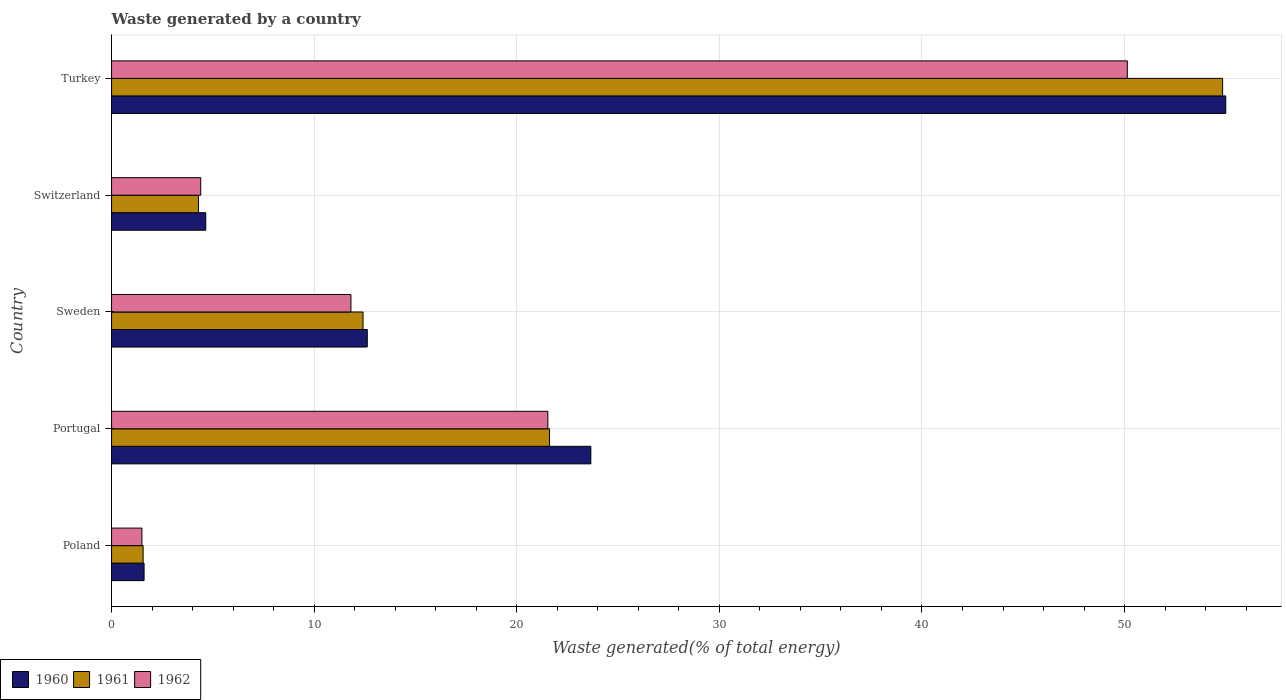How many different coloured bars are there?
Offer a very short reply. 3. Are the number of bars per tick equal to the number of legend labels?
Keep it short and to the point. Yes. Are the number of bars on each tick of the Y-axis equal?
Your answer should be compact. Yes. How many bars are there on the 1st tick from the bottom?
Provide a short and direct response. 3. What is the label of the 3rd group of bars from the top?
Provide a short and direct response. Sweden. What is the total waste generated in 1961 in Portugal?
Provide a succinct answer. 21.62. Across all countries, what is the maximum total waste generated in 1961?
Offer a very short reply. 54.84. Across all countries, what is the minimum total waste generated in 1961?
Provide a short and direct response. 1.56. In which country was the total waste generated in 1961 minimum?
Offer a terse response. Poland. What is the total total waste generated in 1962 in the graph?
Give a very brief answer. 89.39. What is the difference between the total waste generated in 1961 in Poland and that in Sweden?
Your answer should be very brief. -10.85. What is the difference between the total waste generated in 1961 in Switzerland and the total waste generated in 1960 in Portugal?
Give a very brief answer. -19.36. What is the average total waste generated in 1960 per country?
Provide a short and direct response. 19.51. What is the difference between the total waste generated in 1960 and total waste generated in 1961 in Poland?
Offer a very short reply. 0.05. What is the ratio of the total waste generated in 1961 in Poland to that in Sweden?
Provide a succinct answer. 0.13. Is the total waste generated in 1962 in Portugal less than that in Sweden?
Provide a succinct answer. No. Is the difference between the total waste generated in 1960 in Portugal and Turkey greater than the difference between the total waste generated in 1961 in Portugal and Turkey?
Provide a succinct answer. Yes. What is the difference between the highest and the second highest total waste generated in 1961?
Your answer should be compact. 33.22. What is the difference between the highest and the lowest total waste generated in 1960?
Ensure brevity in your answer.  53.39. In how many countries, is the total waste generated in 1960 greater than the average total waste generated in 1960 taken over all countries?
Provide a succinct answer. 2. Is the sum of the total waste generated in 1962 in Portugal and Sweden greater than the maximum total waste generated in 1960 across all countries?
Your answer should be very brief. No. Is it the case that in every country, the sum of the total waste generated in 1961 and total waste generated in 1960 is greater than the total waste generated in 1962?
Provide a succinct answer. Yes. Are all the bars in the graph horizontal?
Your answer should be very brief. Yes. How many countries are there in the graph?
Your answer should be very brief. 5. Does the graph contain any zero values?
Give a very brief answer. No. Does the graph contain grids?
Provide a succinct answer. Yes. What is the title of the graph?
Ensure brevity in your answer.  Waste generated by a country. What is the label or title of the X-axis?
Ensure brevity in your answer.  Waste generated(% of total energy). What is the label or title of the Y-axis?
Your answer should be compact. Country. What is the Waste generated(% of total energy) of 1960 in Poland?
Offer a terse response. 1.6. What is the Waste generated(% of total energy) of 1961 in Poland?
Your response must be concise. 1.56. What is the Waste generated(% of total energy) of 1962 in Poland?
Provide a short and direct response. 1.5. What is the Waste generated(% of total energy) of 1960 in Portugal?
Make the answer very short. 23.66. What is the Waste generated(% of total energy) in 1961 in Portugal?
Provide a short and direct response. 21.62. What is the Waste generated(% of total energy) in 1962 in Portugal?
Ensure brevity in your answer.  21.53. What is the Waste generated(% of total energy) in 1960 in Sweden?
Make the answer very short. 12.62. What is the Waste generated(% of total energy) of 1961 in Sweden?
Ensure brevity in your answer.  12.41. What is the Waste generated(% of total energy) of 1962 in Sweden?
Provide a succinct answer. 11.82. What is the Waste generated(% of total energy) of 1960 in Switzerland?
Provide a succinct answer. 4.65. What is the Waste generated(% of total energy) of 1961 in Switzerland?
Keep it short and to the point. 4.29. What is the Waste generated(% of total energy) of 1962 in Switzerland?
Provide a short and direct response. 4.4. What is the Waste generated(% of total energy) of 1960 in Turkey?
Your answer should be compact. 54.99. What is the Waste generated(% of total energy) of 1961 in Turkey?
Offer a terse response. 54.84. What is the Waste generated(% of total energy) of 1962 in Turkey?
Give a very brief answer. 50.13. Across all countries, what is the maximum Waste generated(% of total energy) of 1960?
Offer a very short reply. 54.99. Across all countries, what is the maximum Waste generated(% of total energy) of 1961?
Ensure brevity in your answer.  54.84. Across all countries, what is the maximum Waste generated(% of total energy) in 1962?
Your response must be concise. 50.13. Across all countries, what is the minimum Waste generated(% of total energy) of 1960?
Your response must be concise. 1.6. Across all countries, what is the minimum Waste generated(% of total energy) in 1961?
Your response must be concise. 1.56. Across all countries, what is the minimum Waste generated(% of total energy) in 1962?
Offer a very short reply. 1.5. What is the total Waste generated(% of total energy) of 1960 in the graph?
Offer a terse response. 97.53. What is the total Waste generated(% of total energy) of 1961 in the graph?
Make the answer very short. 94.72. What is the total Waste generated(% of total energy) of 1962 in the graph?
Provide a succinct answer. 89.39. What is the difference between the Waste generated(% of total energy) of 1960 in Poland and that in Portugal?
Make the answer very short. -22.05. What is the difference between the Waste generated(% of total energy) of 1961 in Poland and that in Portugal?
Keep it short and to the point. -20.06. What is the difference between the Waste generated(% of total energy) in 1962 in Poland and that in Portugal?
Your answer should be very brief. -20.03. What is the difference between the Waste generated(% of total energy) in 1960 in Poland and that in Sweden?
Your response must be concise. -11.02. What is the difference between the Waste generated(% of total energy) in 1961 in Poland and that in Sweden?
Provide a succinct answer. -10.85. What is the difference between the Waste generated(% of total energy) of 1962 in Poland and that in Sweden?
Ensure brevity in your answer.  -10.32. What is the difference between the Waste generated(% of total energy) in 1960 in Poland and that in Switzerland?
Keep it short and to the point. -3.04. What is the difference between the Waste generated(% of total energy) of 1961 in Poland and that in Switzerland?
Your answer should be very brief. -2.73. What is the difference between the Waste generated(% of total energy) in 1962 in Poland and that in Switzerland?
Keep it short and to the point. -2.9. What is the difference between the Waste generated(% of total energy) in 1960 in Poland and that in Turkey?
Give a very brief answer. -53.39. What is the difference between the Waste generated(% of total energy) in 1961 in Poland and that in Turkey?
Your answer should be very brief. -53.28. What is the difference between the Waste generated(% of total energy) in 1962 in Poland and that in Turkey?
Make the answer very short. -48.64. What is the difference between the Waste generated(% of total energy) in 1960 in Portugal and that in Sweden?
Keep it short and to the point. 11.03. What is the difference between the Waste generated(% of total energy) of 1961 in Portugal and that in Sweden?
Your answer should be compact. 9.2. What is the difference between the Waste generated(% of total energy) of 1962 in Portugal and that in Sweden?
Keep it short and to the point. 9.72. What is the difference between the Waste generated(% of total energy) of 1960 in Portugal and that in Switzerland?
Offer a terse response. 19.01. What is the difference between the Waste generated(% of total energy) in 1961 in Portugal and that in Switzerland?
Give a very brief answer. 17.32. What is the difference between the Waste generated(% of total energy) of 1962 in Portugal and that in Switzerland?
Make the answer very short. 17.13. What is the difference between the Waste generated(% of total energy) of 1960 in Portugal and that in Turkey?
Provide a short and direct response. -31.34. What is the difference between the Waste generated(% of total energy) of 1961 in Portugal and that in Turkey?
Make the answer very short. -33.22. What is the difference between the Waste generated(% of total energy) of 1962 in Portugal and that in Turkey?
Your response must be concise. -28.6. What is the difference between the Waste generated(% of total energy) of 1960 in Sweden and that in Switzerland?
Ensure brevity in your answer.  7.97. What is the difference between the Waste generated(% of total energy) of 1961 in Sweden and that in Switzerland?
Ensure brevity in your answer.  8.12. What is the difference between the Waste generated(% of total energy) in 1962 in Sweden and that in Switzerland?
Keep it short and to the point. 7.41. What is the difference between the Waste generated(% of total energy) in 1960 in Sweden and that in Turkey?
Make the answer very short. -42.37. What is the difference between the Waste generated(% of total energy) in 1961 in Sweden and that in Turkey?
Give a very brief answer. -42.43. What is the difference between the Waste generated(% of total energy) in 1962 in Sweden and that in Turkey?
Ensure brevity in your answer.  -38.32. What is the difference between the Waste generated(% of total energy) of 1960 in Switzerland and that in Turkey?
Provide a succinct answer. -50.34. What is the difference between the Waste generated(% of total energy) of 1961 in Switzerland and that in Turkey?
Make the answer very short. -50.55. What is the difference between the Waste generated(% of total energy) in 1962 in Switzerland and that in Turkey?
Your answer should be very brief. -45.73. What is the difference between the Waste generated(% of total energy) of 1960 in Poland and the Waste generated(% of total energy) of 1961 in Portugal?
Keep it short and to the point. -20.01. What is the difference between the Waste generated(% of total energy) in 1960 in Poland and the Waste generated(% of total energy) in 1962 in Portugal?
Provide a short and direct response. -19.93. What is the difference between the Waste generated(% of total energy) of 1961 in Poland and the Waste generated(% of total energy) of 1962 in Portugal?
Your answer should be compact. -19.98. What is the difference between the Waste generated(% of total energy) of 1960 in Poland and the Waste generated(% of total energy) of 1961 in Sweden?
Offer a terse response. -10.81. What is the difference between the Waste generated(% of total energy) in 1960 in Poland and the Waste generated(% of total energy) in 1962 in Sweden?
Your answer should be very brief. -10.21. What is the difference between the Waste generated(% of total energy) of 1961 in Poland and the Waste generated(% of total energy) of 1962 in Sweden?
Your answer should be very brief. -10.26. What is the difference between the Waste generated(% of total energy) of 1960 in Poland and the Waste generated(% of total energy) of 1961 in Switzerland?
Provide a short and direct response. -2.69. What is the difference between the Waste generated(% of total energy) in 1960 in Poland and the Waste generated(% of total energy) in 1962 in Switzerland?
Keep it short and to the point. -2.8. What is the difference between the Waste generated(% of total energy) in 1961 in Poland and the Waste generated(% of total energy) in 1962 in Switzerland?
Provide a short and direct response. -2.84. What is the difference between the Waste generated(% of total energy) of 1960 in Poland and the Waste generated(% of total energy) of 1961 in Turkey?
Provide a succinct answer. -53.23. What is the difference between the Waste generated(% of total energy) of 1960 in Poland and the Waste generated(% of total energy) of 1962 in Turkey?
Ensure brevity in your answer.  -48.53. What is the difference between the Waste generated(% of total energy) in 1961 in Poland and the Waste generated(% of total energy) in 1962 in Turkey?
Your answer should be compact. -48.58. What is the difference between the Waste generated(% of total energy) in 1960 in Portugal and the Waste generated(% of total energy) in 1961 in Sweden?
Provide a short and direct response. 11.24. What is the difference between the Waste generated(% of total energy) in 1960 in Portugal and the Waste generated(% of total energy) in 1962 in Sweden?
Offer a very short reply. 11.84. What is the difference between the Waste generated(% of total energy) in 1961 in Portugal and the Waste generated(% of total energy) in 1962 in Sweden?
Offer a terse response. 9.8. What is the difference between the Waste generated(% of total energy) of 1960 in Portugal and the Waste generated(% of total energy) of 1961 in Switzerland?
Provide a succinct answer. 19.36. What is the difference between the Waste generated(% of total energy) in 1960 in Portugal and the Waste generated(% of total energy) in 1962 in Switzerland?
Your answer should be very brief. 19.25. What is the difference between the Waste generated(% of total energy) in 1961 in Portugal and the Waste generated(% of total energy) in 1962 in Switzerland?
Keep it short and to the point. 17.21. What is the difference between the Waste generated(% of total energy) in 1960 in Portugal and the Waste generated(% of total energy) in 1961 in Turkey?
Keep it short and to the point. -31.18. What is the difference between the Waste generated(% of total energy) in 1960 in Portugal and the Waste generated(% of total energy) in 1962 in Turkey?
Offer a terse response. -26.48. What is the difference between the Waste generated(% of total energy) of 1961 in Portugal and the Waste generated(% of total energy) of 1962 in Turkey?
Provide a short and direct response. -28.52. What is the difference between the Waste generated(% of total energy) in 1960 in Sweden and the Waste generated(% of total energy) in 1961 in Switzerland?
Offer a very short reply. 8.33. What is the difference between the Waste generated(% of total energy) in 1960 in Sweden and the Waste generated(% of total energy) in 1962 in Switzerland?
Give a very brief answer. 8.22. What is the difference between the Waste generated(% of total energy) in 1961 in Sweden and the Waste generated(% of total energy) in 1962 in Switzerland?
Provide a succinct answer. 8.01. What is the difference between the Waste generated(% of total energy) in 1960 in Sweden and the Waste generated(% of total energy) in 1961 in Turkey?
Keep it short and to the point. -42.22. What is the difference between the Waste generated(% of total energy) in 1960 in Sweden and the Waste generated(% of total energy) in 1962 in Turkey?
Your answer should be compact. -37.51. What is the difference between the Waste generated(% of total energy) of 1961 in Sweden and the Waste generated(% of total energy) of 1962 in Turkey?
Your response must be concise. -37.72. What is the difference between the Waste generated(% of total energy) in 1960 in Switzerland and the Waste generated(% of total energy) in 1961 in Turkey?
Offer a terse response. -50.19. What is the difference between the Waste generated(% of total energy) in 1960 in Switzerland and the Waste generated(% of total energy) in 1962 in Turkey?
Your answer should be very brief. -45.48. What is the difference between the Waste generated(% of total energy) in 1961 in Switzerland and the Waste generated(% of total energy) in 1962 in Turkey?
Ensure brevity in your answer.  -45.84. What is the average Waste generated(% of total energy) of 1960 per country?
Your answer should be very brief. 19.51. What is the average Waste generated(% of total energy) of 1961 per country?
Provide a succinct answer. 18.94. What is the average Waste generated(% of total energy) in 1962 per country?
Your response must be concise. 17.88. What is the difference between the Waste generated(% of total energy) in 1960 and Waste generated(% of total energy) in 1961 in Poland?
Your response must be concise. 0.05. What is the difference between the Waste generated(% of total energy) of 1960 and Waste generated(% of total energy) of 1962 in Poland?
Keep it short and to the point. 0.11. What is the difference between the Waste generated(% of total energy) in 1961 and Waste generated(% of total energy) in 1962 in Poland?
Provide a short and direct response. 0.06. What is the difference between the Waste generated(% of total energy) of 1960 and Waste generated(% of total energy) of 1961 in Portugal?
Provide a succinct answer. 2.04. What is the difference between the Waste generated(% of total energy) in 1960 and Waste generated(% of total energy) in 1962 in Portugal?
Your answer should be very brief. 2.12. What is the difference between the Waste generated(% of total energy) of 1961 and Waste generated(% of total energy) of 1962 in Portugal?
Your answer should be very brief. 0.08. What is the difference between the Waste generated(% of total energy) in 1960 and Waste generated(% of total energy) in 1961 in Sweden?
Keep it short and to the point. 0.21. What is the difference between the Waste generated(% of total energy) in 1960 and Waste generated(% of total energy) in 1962 in Sweden?
Make the answer very short. 0.81. What is the difference between the Waste generated(% of total energy) in 1961 and Waste generated(% of total energy) in 1962 in Sweden?
Your response must be concise. 0.6. What is the difference between the Waste generated(% of total energy) of 1960 and Waste generated(% of total energy) of 1961 in Switzerland?
Give a very brief answer. 0.36. What is the difference between the Waste generated(% of total energy) in 1960 and Waste generated(% of total energy) in 1962 in Switzerland?
Your answer should be compact. 0.25. What is the difference between the Waste generated(% of total energy) of 1961 and Waste generated(% of total energy) of 1962 in Switzerland?
Your answer should be very brief. -0.11. What is the difference between the Waste generated(% of total energy) in 1960 and Waste generated(% of total energy) in 1961 in Turkey?
Your response must be concise. 0.16. What is the difference between the Waste generated(% of total energy) in 1960 and Waste generated(% of total energy) in 1962 in Turkey?
Provide a succinct answer. 4.86. What is the difference between the Waste generated(% of total energy) of 1961 and Waste generated(% of total energy) of 1962 in Turkey?
Keep it short and to the point. 4.7. What is the ratio of the Waste generated(% of total energy) of 1960 in Poland to that in Portugal?
Make the answer very short. 0.07. What is the ratio of the Waste generated(% of total energy) of 1961 in Poland to that in Portugal?
Provide a short and direct response. 0.07. What is the ratio of the Waste generated(% of total energy) of 1962 in Poland to that in Portugal?
Offer a very short reply. 0.07. What is the ratio of the Waste generated(% of total energy) in 1960 in Poland to that in Sweden?
Offer a terse response. 0.13. What is the ratio of the Waste generated(% of total energy) in 1961 in Poland to that in Sweden?
Your answer should be very brief. 0.13. What is the ratio of the Waste generated(% of total energy) of 1962 in Poland to that in Sweden?
Offer a very short reply. 0.13. What is the ratio of the Waste generated(% of total energy) in 1960 in Poland to that in Switzerland?
Keep it short and to the point. 0.35. What is the ratio of the Waste generated(% of total energy) in 1961 in Poland to that in Switzerland?
Give a very brief answer. 0.36. What is the ratio of the Waste generated(% of total energy) in 1962 in Poland to that in Switzerland?
Give a very brief answer. 0.34. What is the ratio of the Waste generated(% of total energy) of 1960 in Poland to that in Turkey?
Make the answer very short. 0.03. What is the ratio of the Waste generated(% of total energy) of 1961 in Poland to that in Turkey?
Provide a short and direct response. 0.03. What is the ratio of the Waste generated(% of total energy) of 1962 in Poland to that in Turkey?
Keep it short and to the point. 0.03. What is the ratio of the Waste generated(% of total energy) in 1960 in Portugal to that in Sweden?
Keep it short and to the point. 1.87. What is the ratio of the Waste generated(% of total energy) of 1961 in Portugal to that in Sweden?
Provide a succinct answer. 1.74. What is the ratio of the Waste generated(% of total energy) of 1962 in Portugal to that in Sweden?
Provide a short and direct response. 1.82. What is the ratio of the Waste generated(% of total energy) of 1960 in Portugal to that in Switzerland?
Give a very brief answer. 5.09. What is the ratio of the Waste generated(% of total energy) in 1961 in Portugal to that in Switzerland?
Provide a succinct answer. 5.04. What is the ratio of the Waste generated(% of total energy) in 1962 in Portugal to that in Switzerland?
Your answer should be very brief. 4.89. What is the ratio of the Waste generated(% of total energy) in 1960 in Portugal to that in Turkey?
Offer a very short reply. 0.43. What is the ratio of the Waste generated(% of total energy) in 1961 in Portugal to that in Turkey?
Offer a very short reply. 0.39. What is the ratio of the Waste generated(% of total energy) of 1962 in Portugal to that in Turkey?
Give a very brief answer. 0.43. What is the ratio of the Waste generated(% of total energy) in 1960 in Sweden to that in Switzerland?
Provide a short and direct response. 2.71. What is the ratio of the Waste generated(% of total energy) in 1961 in Sweden to that in Switzerland?
Give a very brief answer. 2.89. What is the ratio of the Waste generated(% of total energy) of 1962 in Sweden to that in Switzerland?
Provide a short and direct response. 2.68. What is the ratio of the Waste generated(% of total energy) in 1960 in Sweden to that in Turkey?
Offer a very short reply. 0.23. What is the ratio of the Waste generated(% of total energy) in 1961 in Sweden to that in Turkey?
Give a very brief answer. 0.23. What is the ratio of the Waste generated(% of total energy) of 1962 in Sweden to that in Turkey?
Make the answer very short. 0.24. What is the ratio of the Waste generated(% of total energy) of 1960 in Switzerland to that in Turkey?
Ensure brevity in your answer.  0.08. What is the ratio of the Waste generated(% of total energy) in 1961 in Switzerland to that in Turkey?
Offer a terse response. 0.08. What is the ratio of the Waste generated(% of total energy) of 1962 in Switzerland to that in Turkey?
Offer a terse response. 0.09. What is the difference between the highest and the second highest Waste generated(% of total energy) in 1960?
Your answer should be compact. 31.34. What is the difference between the highest and the second highest Waste generated(% of total energy) of 1961?
Ensure brevity in your answer.  33.22. What is the difference between the highest and the second highest Waste generated(% of total energy) in 1962?
Your answer should be very brief. 28.6. What is the difference between the highest and the lowest Waste generated(% of total energy) in 1960?
Give a very brief answer. 53.39. What is the difference between the highest and the lowest Waste generated(% of total energy) of 1961?
Keep it short and to the point. 53.28. What is the difference between the highest and the lowest Waste generated(% of total energy) of 1962?
Offer a very short reply. 48.64. 